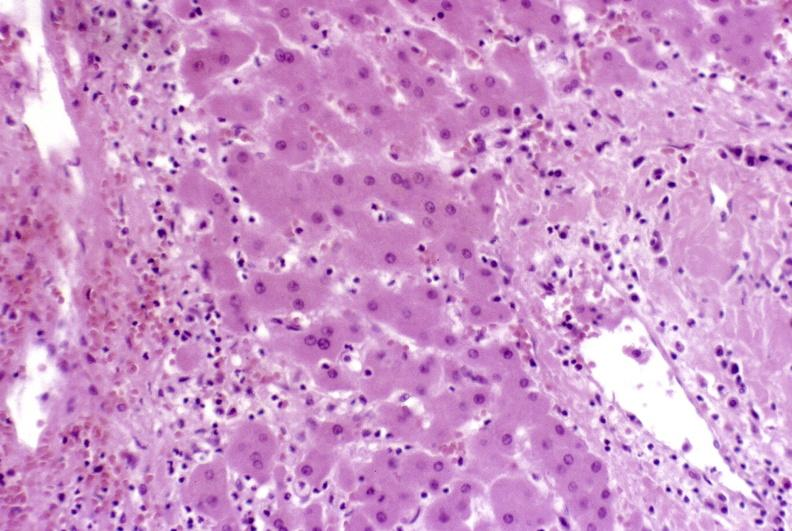does this image show severe acute rejection?
Answer the question using a single word or phrase. Yes 